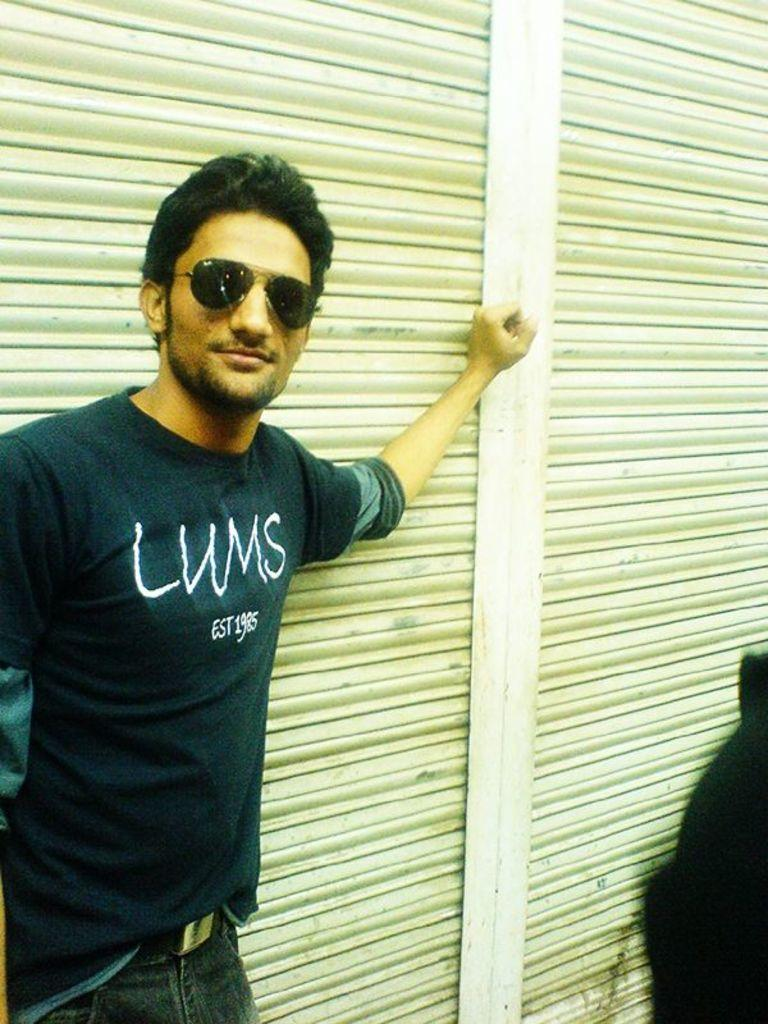What is the main subject of the image? The main subject of the image is a man. What is the man doing in the image? The man is standing near a shutter. Can you describe the man's clothing in the image? The man is wearing a t-shirt and trousers. What accessory is the man wearing in the image? The man is wearing spectacles. What type of writer is the man collaborating with in the image? There is no writer present in the image, and the man is not shown collaborating with anyone. What type of vest is the man wearing in the image? The man is not wearing a vest in the image; he is wearing a t-shirt and trousers. 